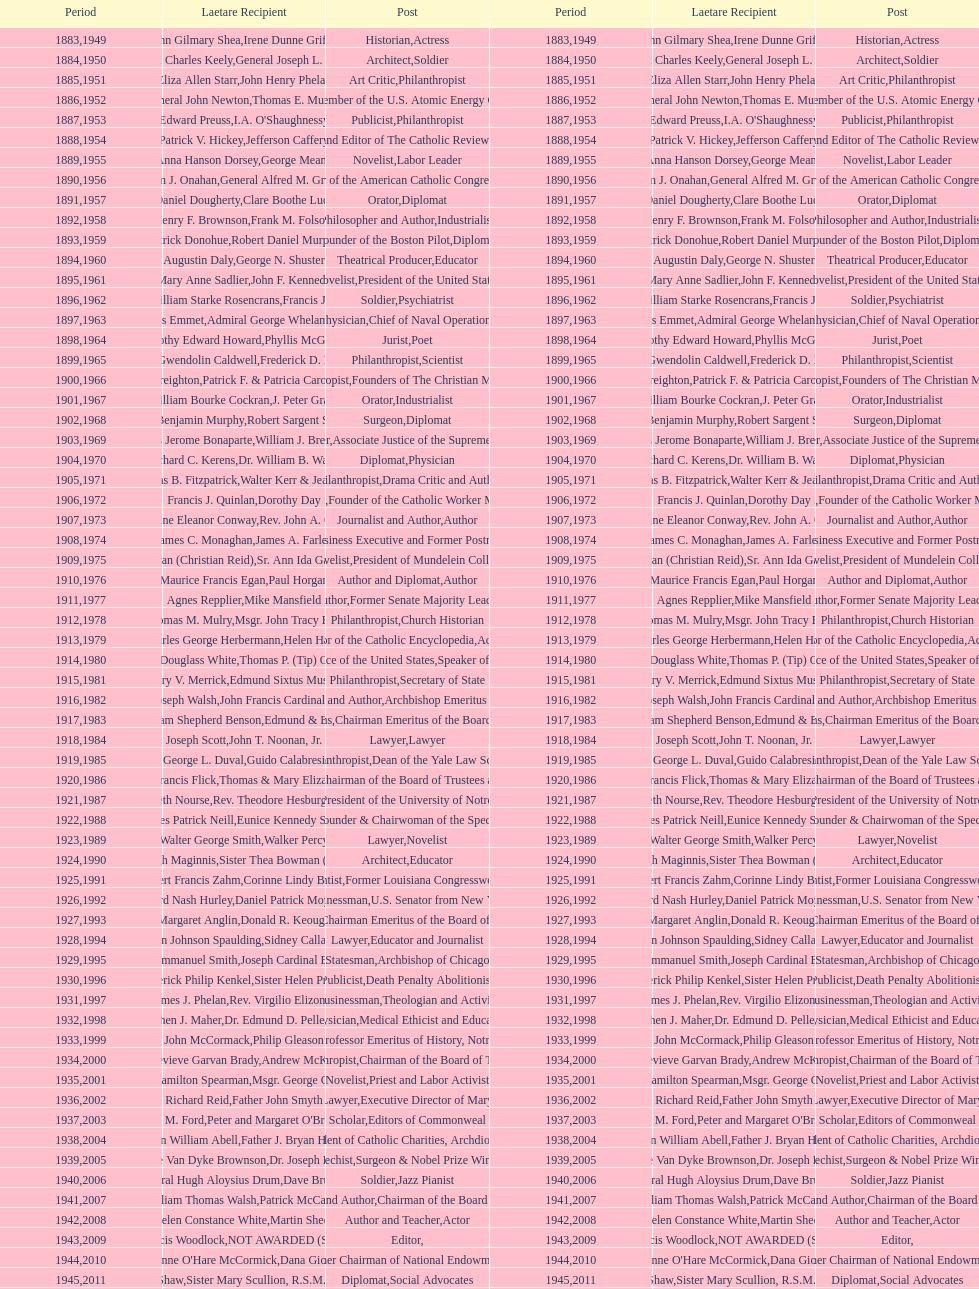What is the name of the laetare medalist listed before edward preuss? General John Newton. 